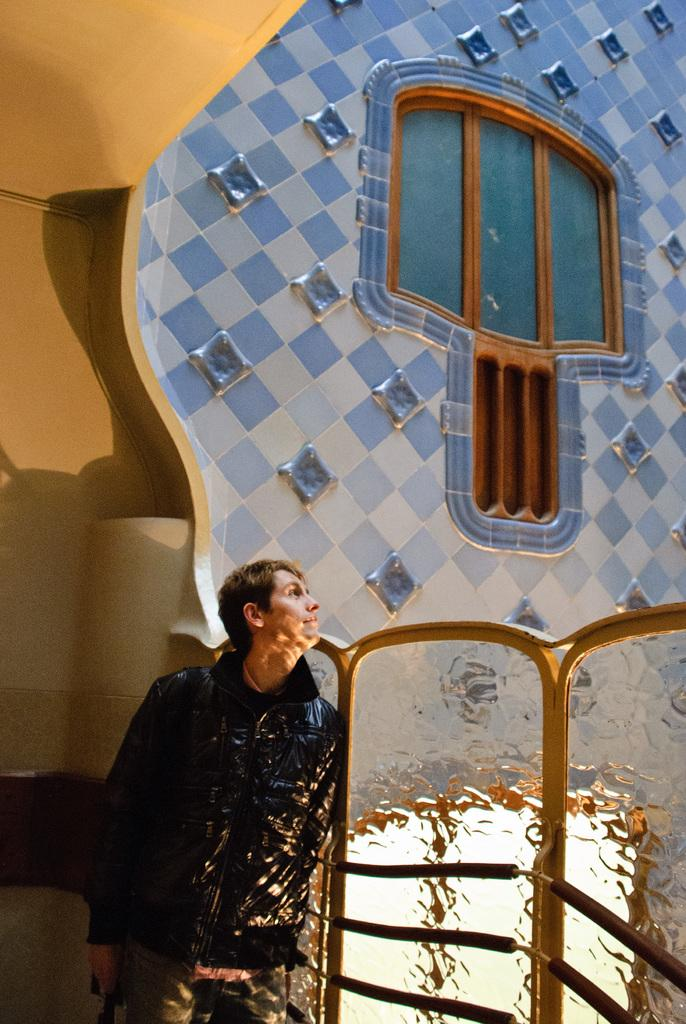What is located on the left side of the image? There is a man on the left side of the image. What can be seen on the right side of the image? There is a railing on the right side of the image. What is visible in the background of the image? There is a wall in the background of the image. What is the name of the account associated with the man in the image? There is no information about an account or the man's name in the image. What sound does the railing make in the image? There is no sound present in the image, as it is a still photograph. 